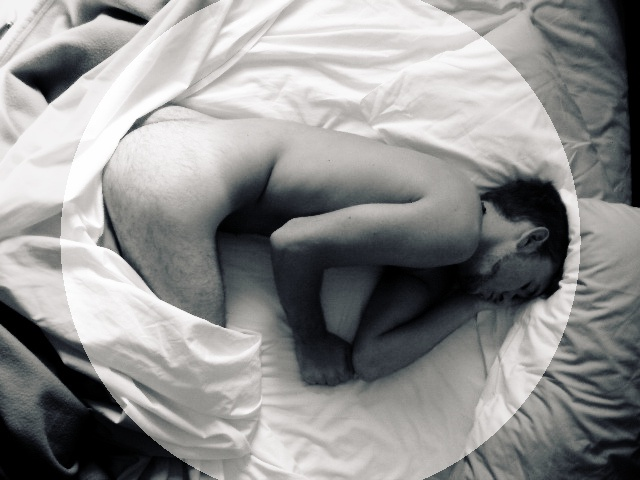Describe the objects in this image and their specific colors. I can see bed in lightgray, darkgray, black, gray, and white tones and people in white, black, gray, darkgray, and lightgray tones in this image. 